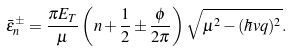<formula> <loc_0><loc_0><loc_500><loc_500>\bar { \varepsilon } _ { n } ^ { \pm } = \frac { \pi E _ { T } } { \mu } \left ( n + \frac { 1 } { 2 } \pm \frac { \phi } { 2 \pi } \right ) \sqrt { \mu ^ { 2 } - ( \hbar { v } q ) ^ { 2 } } .</formula> 